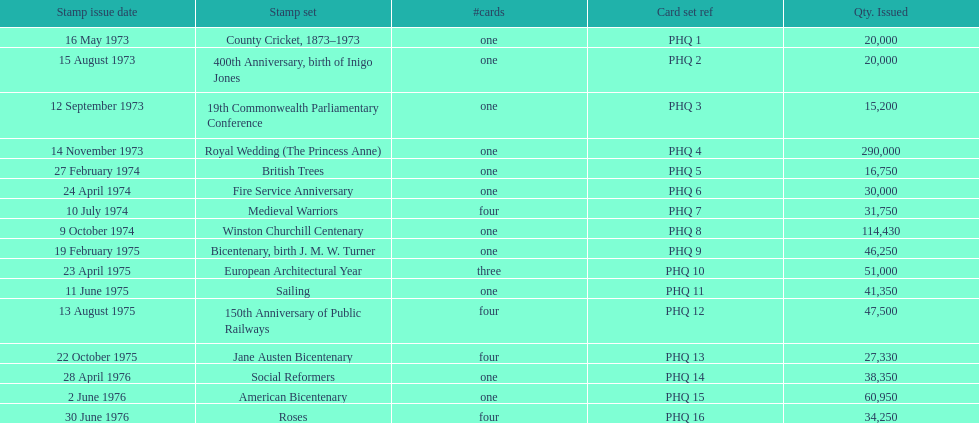How many stamp sets were released in the year 1975? 5. 